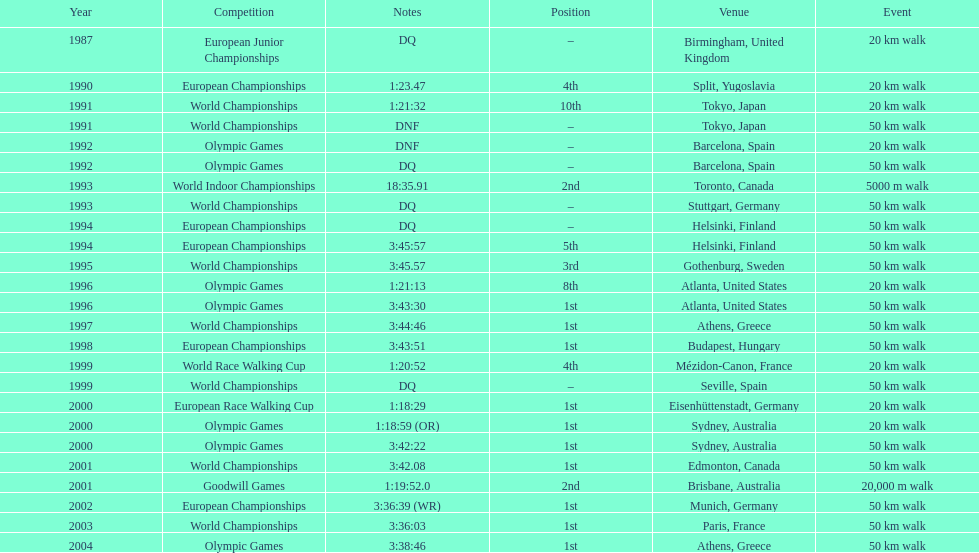What was the name of the competition that took place before the olympic games in 1996? World Championships. 